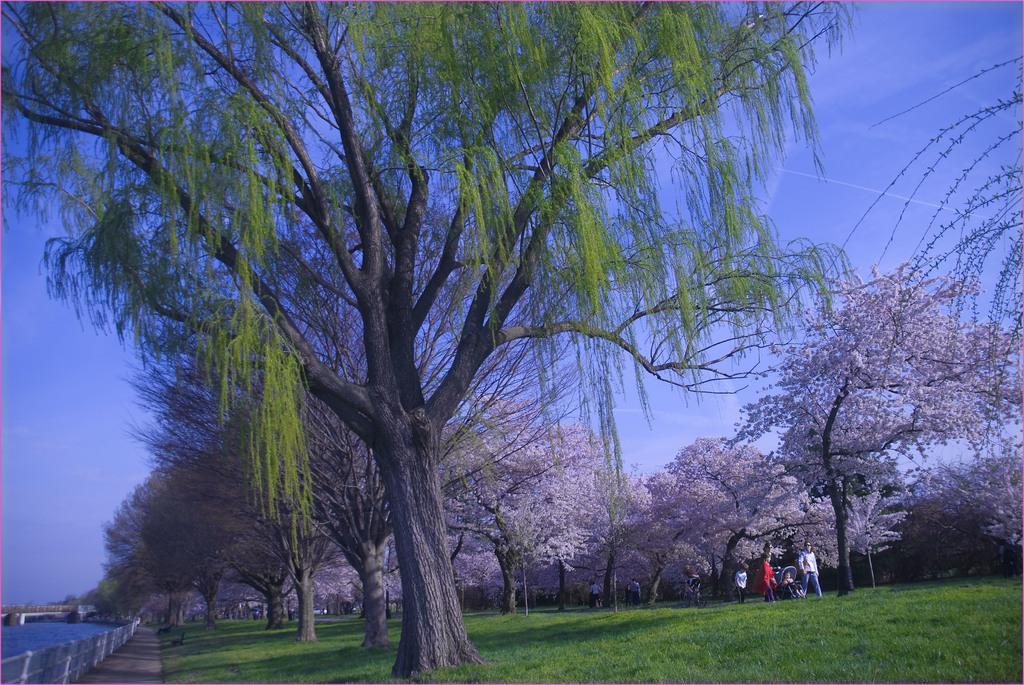Could you give a brief overview of what you see in this image? In the picture we can see a grassy surface beside it, we can see a path and railing and behind it, we can see a water which is blue in color and on the grass surface we can see trees and in the background we can see a sky. 